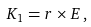<formula> <loc_0><loc_0><loc_500><loc_500>K _ { 1 } = r \times E \, ,</formula> 